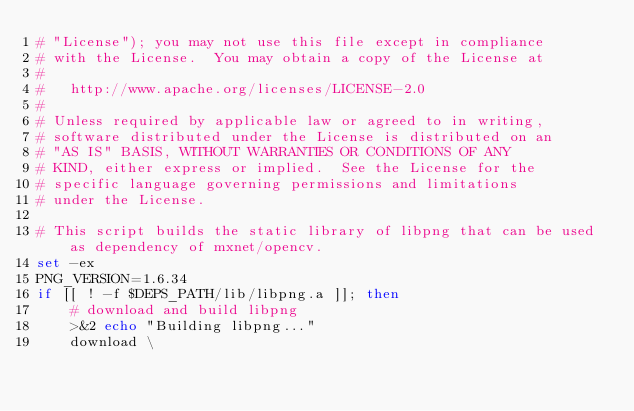Convert code to text. <code><loc_0><loc_0><loc_500><loc_500><_Bash_># "License"); you may not use this file except in compliance
# with the License.  You may obtain a copy of the License at
#
#   http://www.apache.org/licenses/LICENSE-2.0
#
# Unless required by applicable law or agreed to in writing,
# software distributed under the License is distributed on an
# "AS IS" BASIS, WITHOUT WARRANTIES OR CONDITIONS OF ANY
# KIND, either express or implied.  See the License for the
# specific language governing permissions and limitations
# under the License.

# This script builds the static library of libpng that can be used as dependency of mxnet/opencv.
set -ex
PNG_VERSION=1.6.34
if [[ ! -f $DEPS_PATH/lib/libpng.a ]]; then
    # download and build libpng
    >&2 echo "Building libpng..."
    download \</code> 